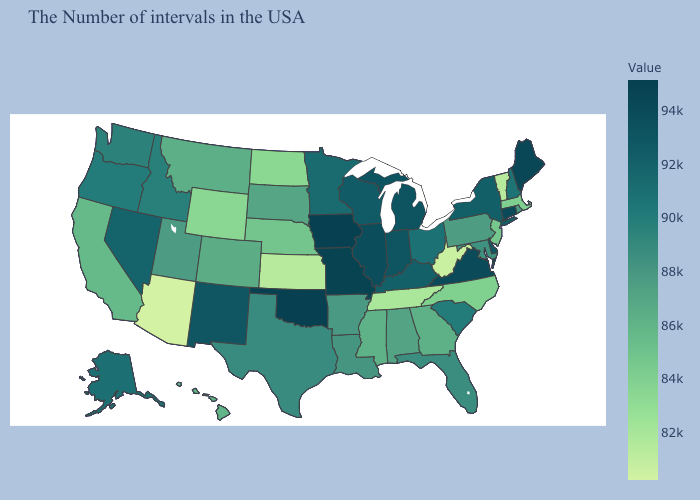Among the states that border Oregon , which have the highest value?
Be succinct. Nevada. Among the states that border Maryland , does Pennsylvania have the lowest value?
Keep it brief. No. Among the states that border Delaware , does Maryland have the highest value?
Give a very brief answer. Yes. Does Nevada have a lower value than Virginia?
Concise answer only. Yes. Among the states that border West Virginia , which have the lowest value?
Write a very short answer. Pennsylvania. Does Wisconsin have a higher value than Virginia?
Answer briefly. No. 